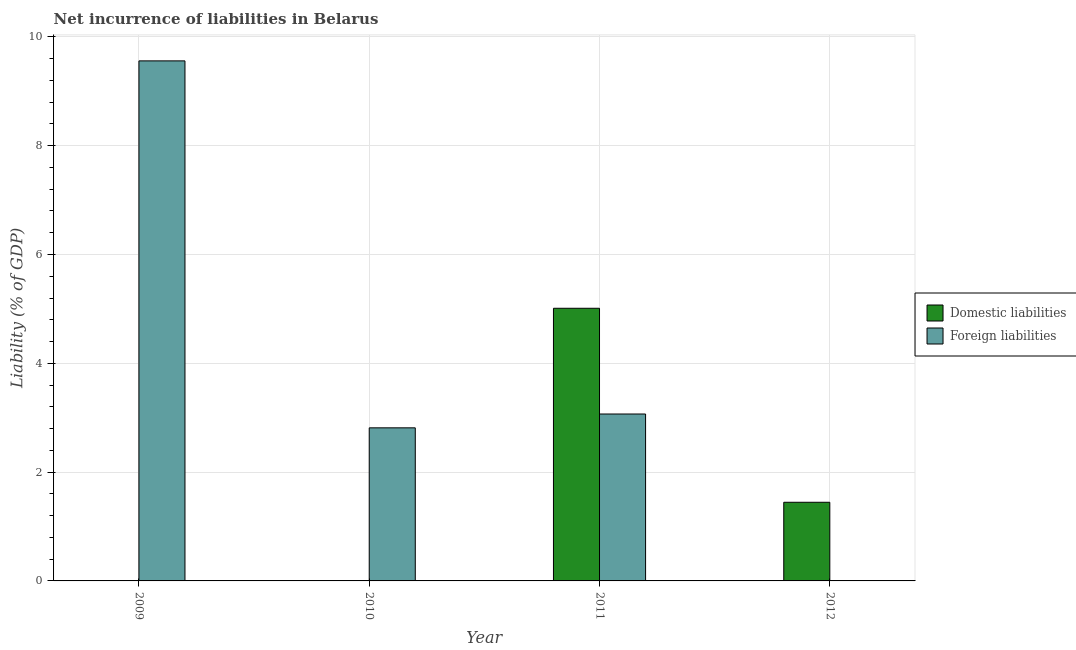How many different coloured bars are there?
Keep it short and to the point. 2. Are the number of bars per tick equal to the number of legend labels?
Offer a very short reply. No. Are the number of bars on each tick of the X-axis equal?
Ensure brevity in your answer.  No. What is the incurrence of foreign liabilities in 2010?
Offer a very short reply. 2.81. Across all years, what is the maximum incurrence of domestic liabilities?
Offer a very short reply. 5.01. What is the total incurrence of foreign liabilities in the graph?
Offer a terse response. 15.44. What is the difference between the incurrence of foreign liabilities in 2009 and that in 2010?
Offer a terse response. 6.74. What is the difference between the incurrence of domestic liabilities in 2009 and the incurrence of foreign liabilities in 2012?
Ensure brevity in your answer.  -1.45. What is the average incurrence of foreign liabilities per year?
Ensure brevity in your answer.  3.86. In how many years, is the incurrence of foreign liabilities greater than 1.6 %?
Give a very brief answer. 3. What is the ratio of the incurrence of domestic liabilities in 2011 to that in 2012?
Provide a succinct answer. 3.47. Is the incurrence of foreign liabilities in 2010 less than that in 2011?
Make the answer very short. Yes. What is the difference between the highest and the second highest incurrence of foreign liabilities?
Make the answer very short. 6.49. What is the difference between the highest and the lowest incurrence of foreign liabilities?
Make the answer very short. 9.56. In how many years, is the incurrence of foreign liabilities greater than the average incurrence of foreign liabilities taken over all years?
Provide a succinct answer. 1. How many bars are there?
Keep it short and to the point. 5. Are all the bars in the graph horizontal?
Keep it short and to the point. No. How many years are there in the graph?
Your answer should be very brief. 4. What is the difference between two consecutive major ticks on the Y-axis?
Provide a short and direct response. 2. Are the values on the major ticks of Y-axis written in scientific E-notation?
Offer a very short reply. No. Does the graph contain any zero values?
Offer a very short reply. Yes. Where does the legend appear in the graph?
Your answer should be very brief. Center right. How are the legend labels stacked?
Your answer should be compact. Vertical. What is the title of the graph?
Give a very brief answer. Net incurrence of liabilities in Belarus. What is the label or title of the X-axis?
Give a very brief answer. Year. What is the label or title of the Y-axis?
Provide a succinct answer. Liability (% of GDP). What is the Liability (% of GDP) in Foreign liabilities in 2009?
Your answer should be compact. 9.56. What is the Liability (% of GDP) of Domestic liabilities in 2010?
Keep it short and to the point. 0. What is the Liability (% of GDP) of Foreign liabilities in 2010?
Offer a terse response. 2.81. What is the Liability (% of GDP) of Domestic liabilities in 2011?
Your answer should be compact. 5.01. What is the Liability (% of GDP) of Foreign liabilities in 2011?
Make the answer very short. 3.07. What is the Liability (% of GDP) in Domestic liabilities in 2012?
Provide a succinct answer. 1.45. Across all years, what is the maximum Liability (% of GDP) in Domestic liabilities?
Make the answer very short. 5.01. Across all years, what is the maximum Liability (% of GDP) of Foreign liabilities?
Give a very brief answer. 9.56. Across all years, what is the minimum Liability (% of GDP) in Domestic liabilities?
Keep it short and to the point. 0. Across all years, what is the minimum Liability (% of GDP) in Foreign liabilities?
Ensure brevity in your answer.  0. What is the total Liability (% of GDP) in Domestic liabilities in the graph?
Provide a succinct answer. 6.46. What is the total Liability (% of GDP) in Foreign liabilities in the graph?
Keep it short and to the point. 15.44. What is the difference between the Liability (% of GDP) in Foreign liabilities in 2009 and that in 2010?
Your answer should be very brief. 6.74. What is the difference between the Liability (% of GDP) of Foreign liabilities in 2009 and that in 2011?
Give a very brief answer. 6.49. What is the difference between the Liability (% of GDP) in Foreign liabilities in 2010 and that in 2011?
Offer a terse response. -0.25. What is the difference between the Liability (% of GDP) in Domestic liabilities in 2011 and that in 2012?
Provide a short and direct response. 3.57. What is the average Liability (% of GDP) in Domestic liabilities per year?
Offer a terse response. 1.61. What is the average Liability (% of GDP) in Foreign liabilities per year?
Provide a succinct answer. 3.86. In the year 2011, what is the difference between the Liability (% of GDP) in Domestic liabilities and Liability (% of GDP) in Foreign liabilities?
Your response must be concise. 1.94. What is the ratio of the Liability (% of GDP) in Foreign liabilities in 2009 to that in 2010?
Make the answer very short. 3.4. What is the ratio of the Liability (% of GDP) in Foreign liabilities in 2009 to that in 2011?
Make the answer very short. 3.12. What is the ratio of the Liability (% of GDP) in Foreign liabilities in 2010 to that in 2011?
Ensure brevity in your answer.  0.92. What is the ratio of the Liability (% of GDP) in Domestic liabilities in 2011 to that in 2012?
Offer a very short reply. 3.47. What is the difference between the highest and the second highest Liability (% of GDP) of Foreign liabilities?
Your answer should be compact. 6.49. What is the difference between the highest and the lowest Liability (% of GDP) in Domestic liabilities?
Offer a terse response. 5.01. What is the difference between the highest and the lowest Liability (% of GDP) of Foreign liabilities?
Offer a very short reply. 9.56. 